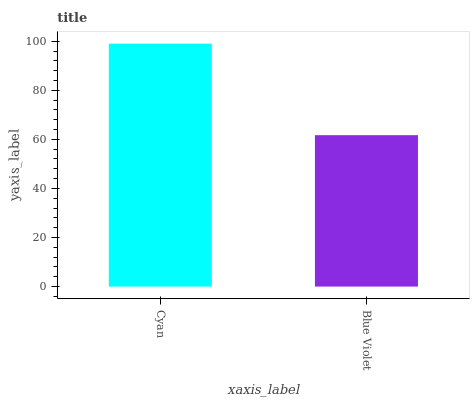Is Blue Violet the minimum?
Answer yes or no. Yes. Is Cyan the maximum?
Answer yes or no. Yes. Is Blue Violet the maximum?
Answer yes or no. No. Is Cyan greater than Blue Violet?
Answer yes or no. Yes. Is Blue Violet less than Cyan?
Answer yes or no. Yes. Is Blue Violet greater than Cyan?
Answer yes or no. No. Is Cyan less than Blue Violet?
Answer yes or no. No. Is Cyan the high median?
Answer yes or no. Yes. Is Blue Violet the low median?
Answer yes or no. Yes. Is Blue Violet the high median?
Answer yes or no. No. Is Cyan the low median?
Answer yes or no. No. 